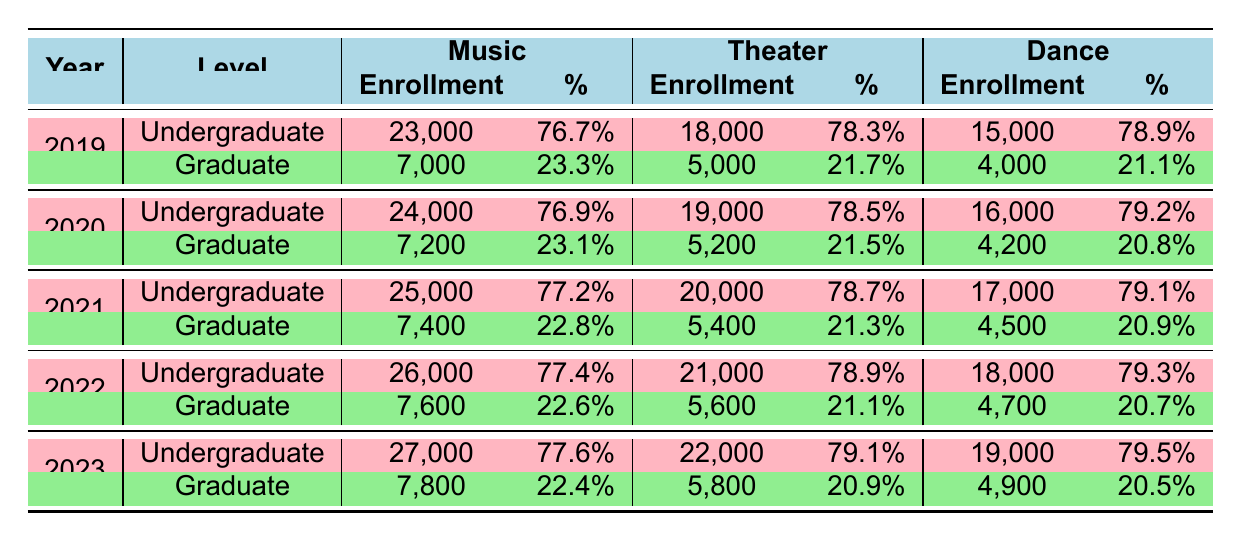What was the total enrollment in music programs in 2022? The enrollment in music programs in 2022 is 26,000 (undergraduate) + 7,600 (graduate) = 33,600.
Answer: 33600 In which year did theater programs have the highest total enrollment? To find the total enrollment for theater programs, we add undergraduate and graduate enrollments for each year. The totals are: 2019 - 23,000; 2020 - 24,200; 2021 - 25,400; 2022 - 26,600; 2023 - 27,800. The highest total is in 2023 with an enrollment of 27,800.
Answer: 2023 Did the enrollment in dance graduate programs ever exceed 5,000 in the years shown? The enrollment for dance graduate programs for each year is: 4,000 (2019), 4,200 (2020), 4,500 (2021), 4,700 (2022), and 4,900 (2023). None of these values exceeded 5,000.
Answer: No What is the percentage increase in undergraduate enrollment for music programs from 2019 to 2023? The undergraduate enrollment for music in 2019 was 23,000 and in 2023 it was 27,000. The increase is (27,000 - 23,000)/23,000 = 4,000/23,000, which is approximately 0.1739 or 17.39%.
Answer: 17.39% In which year was the percentage of graduate music enrollment the lowest? The percentage of graduate music enrollment for each year is as follows: 2019 - 23.3%, 2020 - 23.1%, 2021 - 22.8%, 2022 - 22.6%, and 2023 - 22.4%. The lowest percentage is in 2022 at 22.6%.
Answer: 2022 What was the combined enrollment of undergraduate and graduate students in dance programs in 2021? The combined enrollment in dance programs for 2021 is 17,000 (undergraduate) + 4,500 (graduate) = 21,500.
Answer: 21500 Is the percentage of graduate students in theater programs generally increasing or decreasing from 2019 to 2023? The percentages for graduate students in theater from 2019 to 2023 are: 21.7%, 21.5%, 21.3%, 21.1%, and 20.9%. The trend shows a decrease over the years.
Answer: Decreasing What is the average total enrollment for all programs (music, theater, and dance) in 2020? First, calculate total enrollment for each program: Music - 24,000 + 7,200 = 31,200, Theater - 19,000 + 5,200 = 24,200, and Dance - 16,000 + 4,200 = 20,200. The total enrollment for all programs is 31,200 + 24,200 + 20,200 = 75,600. The average is 75,600/3 = 25,200.
Answer: 25200 